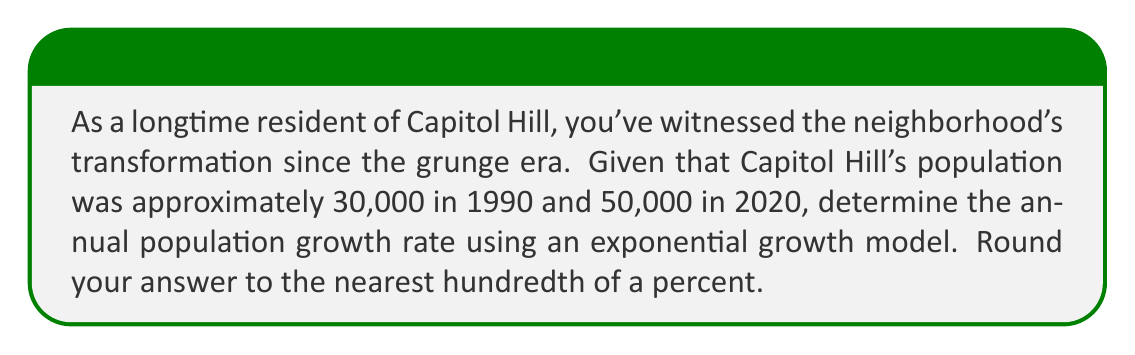Teach me how to tackle this problem. Let's approach this step-by-step using the exponential growth model:

1) The exponential growth model is given by:
   $$P(t) = P_0 \cdot e^{rt}$$
   where $P(t)$ is the population at time $t$, $P_0$ is the initial population, $r$ is the growth rate, and $t$ is the time in years.

2) We know:
   $P_0 = 30,000$ (population in 1990)
   $P(30) = 50,000$ (population in 2020, 30 years later)
   $t = 30$ years

3) Let's plug these into our equation:
   $$50,000 = 30,000 \cdot e^{30r}$$

4) Divide both sides by 30,000:
   $$\frac{50,000}{30,000} = e^{30r}$$

5) Simplify:
   $$\frac{5}{3} = e^{30r}$$

6) Take the natural log of both sides:
   $$\ln(\frac{5}{3}) = \ln(e^{30r})$$

7) Simplify the right side:
   $$\ln(\frac{5}{3}) = 30r$$

8) Solve for $r$:
   $$r = \frac{\ln(\frac{5}{3})}{30}$$

9) Calculate:
   $$r \approx 0.01655$$

10) Convert to a percentage and round to the nearest hundredth:
    $$r \approx 1.66\%$$
Answer: 1.66% 